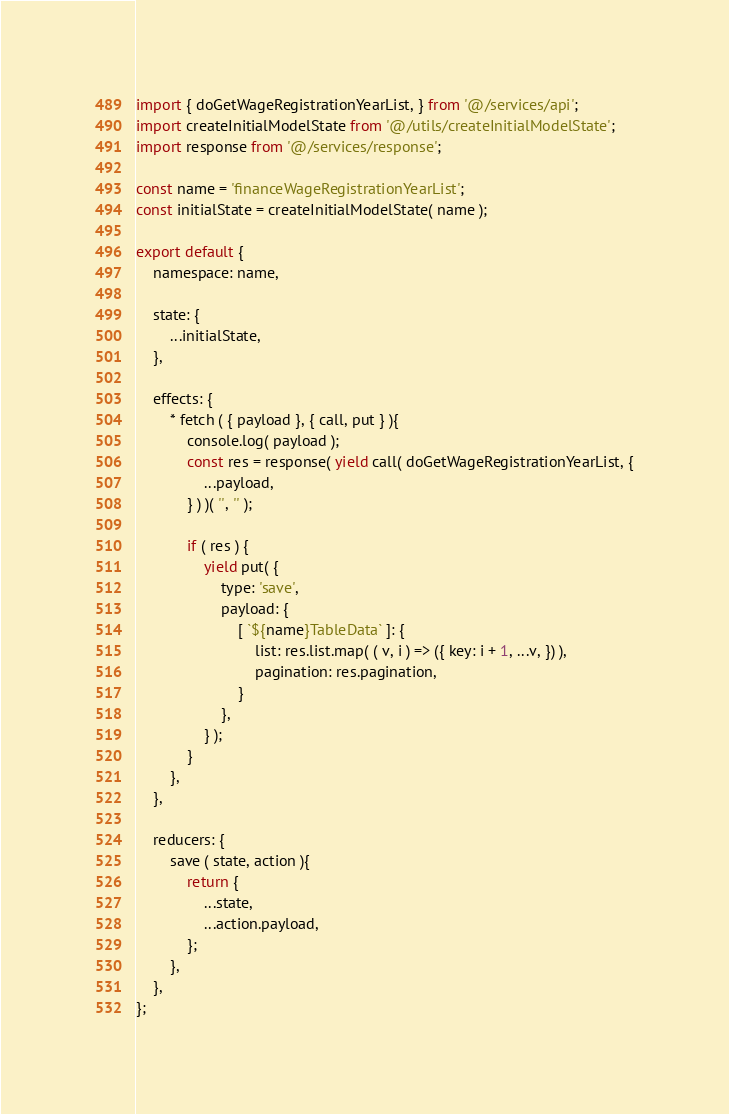Convert code to text. <code><loc_0><loc_0><loc_500><loc_500><_JavaScript_>import { doGetWageRegistrationYearList, } from '@/services/api';
import createInitialModelState from '@/utils/createInitialModelState';
import response from '@/services/response';

const name = 'financeWageRegistrationYearList';
const initialState = createInitialModelState( name );

export default {
	namespace: name,
	
	state: {
		...initialState,
	},
	
	effects: {
		* fetch ( { payload }, { call, put } ){
			console.log( payload );
			const res = response( yield call( doGetWageRegistrationYearList, {
				...payload,
			} ) )( '', '' );
			
			if ( res ) {
				yield put( {
					type: 'save',
					payload: {
						[ `${name}TableData` ]: {
							list: res.list.map( ( v, i ) => ({ key: i + 1, ...v, }) ),
							pagination: res.pagination,
						}
					},
				} );
			}
		},
	},
	
	reducers: {
		save ( state, action ){
			return {
				...state,
				...action.payload,
			};
		},
	},
};
</code> 